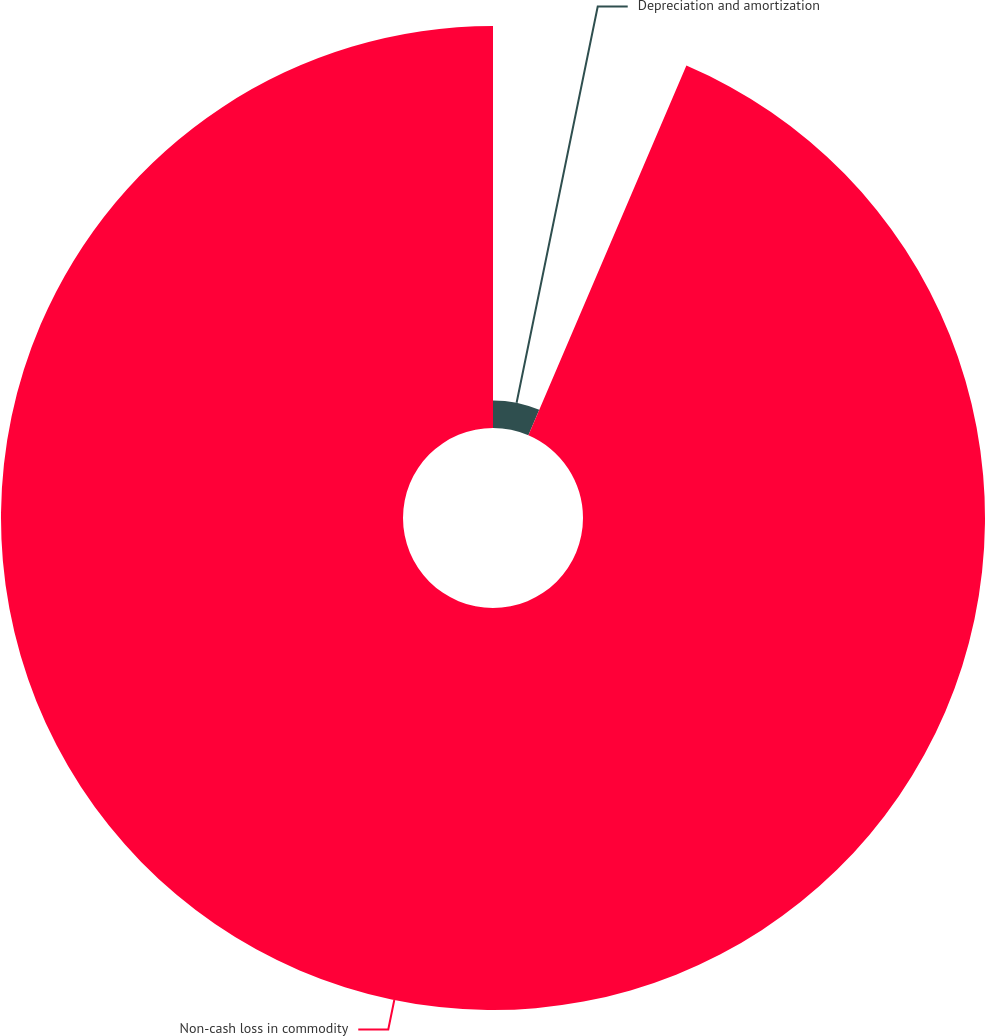Convert chart to OTSL. <chart><loc_0><loc_0><loc_500><loc_500><pie_chart><fcel>Depreciation and amortization<fcel>Non-cash loss in commodity<nl><fcel>6.43%<fcel>93.57%<nl></chart> 